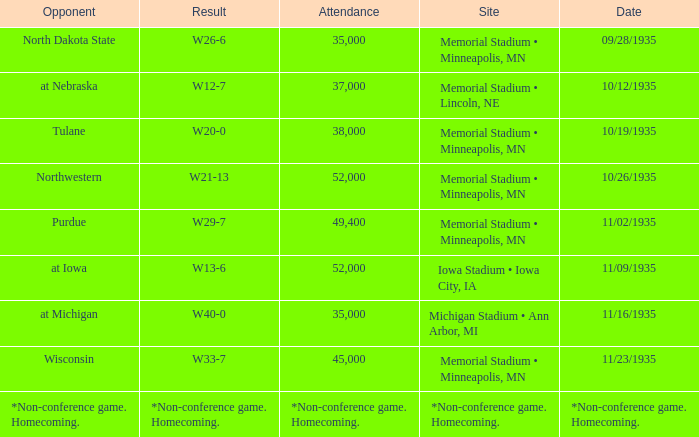Who was the opponent against which the result was w20-0? Tulane. 